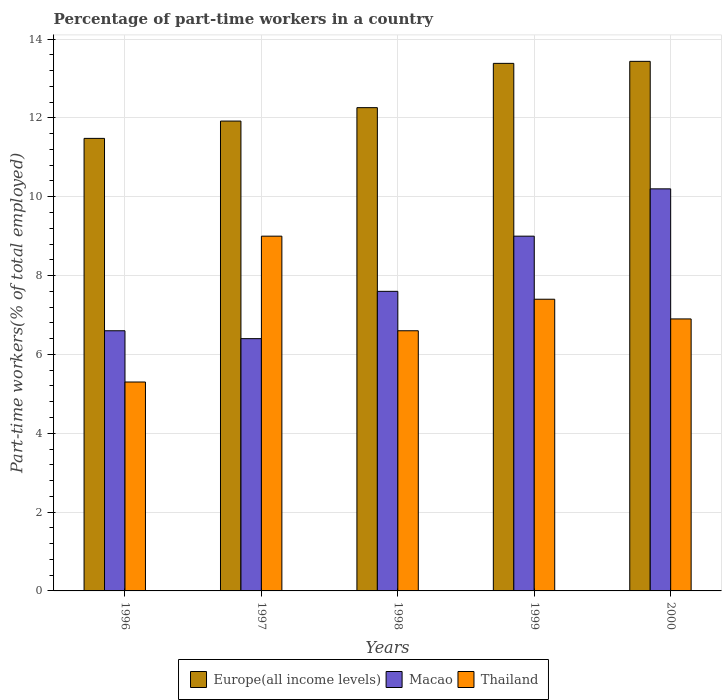How many different coloured bars are there?
Offer a very short reply. 3. How many bars are there on the 5th tick from the right?
Ensure brevity in your answer.  3. What is the label of the 5th group of bars from the left?
Provide a short and direct response. 2000. In how many cases, is the number of bars for a given year not equal to the number of legend labels?
Offer a very short reply. 0. What is the percentage of part-time workers in Macao in 1996?
Provide a succinct answer. 6.6. Across all years, what is the maximum percentage of part-time workers in Macao?
Your answer should be compact. 10.2. Across all years, what is the minimum percentage of part-time workers in Macao?
Keep it short and to the point. 6.4. What is the total percentage of part-time workers in Europe(all income levels) in the graph?
Ensure brevity in your answer.  62.48. What is the difference between the percentage of part-time workers in Macao in 1997 and that in 2000?
Offer a terse response. -3.8. What is the difference between the percentage of part-time workers in Thailand in 2000 and the percentage of part-time workers in Macao in 1997?
Offer a very short reply. 0.5. What is the average percentage of part-time workers in Europe(all income levels) per year?
Offer a very short reply. 12.5. In the year 1998, what is the difference between the percentage of part-time workers in Europe(all income levels) and percentage of part-time workers in Macao?
Your answer should be compact. 4.66. What is the ratio of the percentage of part-time workers in Macao in 1996 to that in 1998?
Offer a very short reply. 0.87. Is the percentage of part-time workers in Macao in 1996 less than that in 1999?
Provide a succinct answer. Yes. Is the difference between the percentage of part-time workers in Europe(all income levels) in 1996 and 1998 greater than the difference between the percentage of part-time workers in Macao in 1996 and 1998?
Provide a succinct answer. Yes. What is the difference between the highest and the second highest percentage of part-time workers in Macao?
Ensure brevity in your answer.  1.2. What is the difference between the highest and the lowest percentage of part-time workers in Thailand?
Keep it short and to the point. 3.7. In how many years, is the percentage of part-time workers in Macao greater than the average percentage of part-time workers in Macao taken over all years?
Offer a very short reply. 2. What does the 1st bar from the left in 1998 represents?
Give a very brief answer. Europe(all income levels). What does the 2nd bar from the right in 1998 represents?
Keep it short and to the point. Macao. Is it the case that in every year, the sum of the percentage of part-time workers in Macao and percentage of part-time workers in Thailand is greater than the percentage of part-time workers in Europe(all income levels)?
Offer a terse response. Yes. How many bars are there?
Offer a terse response. 15. Are all the bars in the graph horizontal?
Ensure brevity in your answer.  No. Does the graph contain any zero values?
Your answer should be compact. No. How are the legend labels stacked?
Offer a very short reply. Horizontal. What is the title of the graph?
Provide a succinct answer. Percentage of part-time workers in a country. Does "Tuvalu" appear as one of the legend labels in the graph?
Your answer should be compact. No. What is the label or title of the Y-axis?
Give a very brief answer. Part-time workers(% of total employed). What is the Part-time workers(% of total employed) of Europe(all income levels) in 1996?
Your answer should be very brief. 11.48. What is the Part-time workers(% of total employed) in Macao in 1996?
Offer a terse response. 6.6. What is the Part-time workers(% of total employed) of Thailand in 1996?
Make the answer very short. 5.3. What is the Part-time workers(% of total employed) of Europe(all income levels) in 1997?
Make the answer very short. 11.92. What is the Part-time workers(% of total employed) of Macao in 1997?
Ensure brevity in your answer.  6.4. What is the Part-time workers(% of total employed) in Thailand in 1997?
Make the answer very short. 9. What is the Part-time workers(% of total employed) of Europe(all income levels) in 1998?
Offer a very short reply. 12.26. What is the Part-time workers(% of total employed) of Macao in 1998?
Offer a terse response. 7.6. What is the Part-time workers(% of total employed) of Thailand in 1998?
Offer a terse response. 6.6. What is the Part-time workers(% of total employed) in Europe(all income levels) in 1999?
Give a very brief answer. 13.38. What is the Part-time workers(% of total employed) in Macao in 1999?
Keep it short and to the point. 9. What is the Part-time workers(% of total employed) in Thailand in 1999?
Your answer should be compact. 7.4. What is the Part-time workers(% of total employed) of Europe(all income levels) in 2000?
Offer a very short reply. 13.43. What is the Part-time workers(% of total employed) of Macao in 2000?
Your answer should be very brief. 10.2. What is the Part-time workers(% of total employed) in Thailand in 2000?
Make the answer very short. 6.9. Across all years, what is the maximum Part-time workers(% of total employed) in Europe(all income levels)?
Your answer should be compact. 13.43. Across all years, what is the maximum Part-time workers(% of total employed) of Macao?
Offer a very short reply. 10.2. Across all years, what is the maximum Part-time workers(% of total employed) of Thailand?
Your answer should be compact. 9. Across all years, what is the minimum Part-time workers(% of total employed) in Europe(all income levels)?
Give a very brief answer. 11.48. Across all years, what is the minimum Part-time workers(% of total employed) in Macao?
Offer a very short reply. 6.4. Across all years, what is the minimum Part-time workers(% of total employed) in Thailand?
Make the answer very short. 5.3. What is the total Part-time workers(% of total employed) in Europe(all income levels) in the graph?
Give a very brief answer. 62.48. What is the total Part-time workers(% of total employed) of Macao in the graph?
Offer a terse response. 39.8. What is the total Part-time workers(% of total employed) of Thailand in the graph?
Your response must be concise. 35.2. What is the difference between the Part-time workers(% of total employed) in Europe(all income levels) in 1996 and that in 1997?
Keep it short and to the point. -0.44. What is the difference between the Part-time workers(% of total employed) in Macao in 1996 and that in 1997?
Provide a succinct answer. 0.2. What is the difference between the Part-time workers(% of total employed) of Europe(all income levels) in 1996 and that in 1998?
Make the answer very short. -0.78. What is the difference between the Part-time workers(% of total employed) in Macao in 1996 and that in 1998?
Offer a terse response. -1. What is the difference between the Part-time workers(% of total employed) of Europe(all income levels) in 1996 and that in 1999?
Provide a succinct answer. -1.9. What is the difference between the Part-time workers(% of total employed) of Macao in 1996 and that in 1999?
Offer a very short reply. -2.4. What is the difference between the Part-time workers(% of total employed) of Thailand in 1996 and that in 1999?
Your answer should be compact. -2.1. What is the difference between the Part-time workers(% of total employed) in Europe(all income levels) in 1996 and that in 2000?
Your answer should be very brief. -1.95. What is the difference between the Part-time workers(% of total employed) of Thailand in 1996 and that in 2000?
Keep it short and to the point. -1.6. What is the difference between the Part-time workers(% of total employed) of Europe(all income levels) in 1997 and that in 1998?
Give a very brief answer. -0.34. What is the difference between the Part-time workers(% of total employed) of Thailand in 1997 and that in 1998?
Provide a short and direct response. 2.4. What is the difference between the Part-time workers(% of total employed) of Europe(all income levels) in 1997 and that in 1999?
Give a very brief answer. -1.46. What is the difference between the Part-time workers(% of total employed) in Thailand in 1997 and that in 1999?
Your answer should be very brief. 1.6. What is the difference between the Part-time workers(% of total employed) in Europe(all income levels) in 1997 and that in 2000?
Your response must be concise. -1.51. What is the difference between the Part-time workers(% of total employed) of Europe(all income levels) in 1998 and that in 1999?
Offer a terse response. -1.12. What is the difference between the Part-time workers(% of total employed) of Thailand in 1998 and that in 1999?
Your answer should be very brief. -0.8. What is the difference between the Part-time workers(% of total employed) in Europe(all income levels) in 1998 and that in 2000?
Ensure brevity in your answer.  -1.17. What is the difference between the Part-time workers(% of total employed) in Macao in 1998 and that in 2000?
Provide a short and direct response. -2.6. What is the difference between the Part-time workers(% of total employed) of Europe(all income levels) in 1999 and that in 2000?
Provide a short and direct response. -0.05. What is the difference between the Part-time workers(% of total employed) of Macao in 1999 and that in 2000?
Offer a terse response. -1.2. What is the difference between the Part-time workers(% of total employed) of Thailand in 1999 and that in 2000?
Keep it short and to the point. 0.5. What is the difference between the Part-time workers(% of total employed) in Europe(all income levels) in 1996 and the Part-time workers(% of total employed) in Macao in 1997?
Ensure brevity in your answer.  5.08. What is the difference between the Part-time workers(% of total employed) in Europe(all income levels) in 1996 and the Part-time workers(% of total employed) in Thailand in 1997?
Provide a succinct answer. 2.48. What is the difference between the Part-time workers(% of total employed) of Europe(all income levels) in 1996 and the Part-time workers(% of total employed) of Macao in 1998?
Offer a very short reply. 3.88. What is the difference between the Part-time workers(% of total employed) of Europe(all income levels) in 1996 and the Part-time workers(% of total employed) of Thailand in 1998?
Ensure brevity in your answer.  4.88. What is the difference between the Part-time workers(% of total employed) of Macao in 1996 and the Part-time workers(% of total employed) of Thailand in 1998?
Offer a very short reply. 0. What is the difference between the Part-time workers(% of total employed) of Europe(all income levels) in 1996 and the Part-time workers(% of total employed) of Macao in 1999?
Your answer should be compact. 2.48. What is the difference between the Part-time workers(% of total employed) in Europe(all income levels) in 1996 and the Part-time workers(% of total employed) in Thailand in 1999?
Provide a succinct answer. 4.08. What is the difference between the Part-time workers(% of total employed) of Macao in 1996 and the Part-time workers(% of total employed) of Thailand in 1999?
Your answer should be very brief. -0.8. What is the difference between the Part-time workers(% of total employed) of Europe(all income levels) in 1996 and the Part-time workers(% of total employed) of Macao in 2000?
Make the answer very short. 1.28. What is the difference between the Part-time workers(% of total employed) in Europe(all income levels) in 1996 and the Part-time workers(% of total employed) in Thailand in 2000?
Offer a terse response. 4.58. What is the difference between the Part-time workers(% of total employed) of Macao in 1996 and the Part-time workers(% of total employed) of Thailand in 2000?
Offer a very short reply. -0.3. What is the difference between the Part-time workers(% of total employed) in Europe(all income levels) in 1997 and the Part-time workers(% of total employed) in Macao in 1998?
Your answer should be very brief. 4.32. What is the difference between the Part-time workers(% of total employed) in Europe(all income levels) in 1997 and the Part-time workers(% of total employed) in Thailand in 1998?
Your answer should be very brief. 5.32. What is the difference between the Part-time workers(% of total employed) of Macao in 1997 and the Part-time workers(% of total employed) of Thailand in 1998?
Provide a short and direct response. -0.2. What is the difference between the Part-time workers(% of total employed) of Europe(all income levels) in 1997 and the Part-time workers(% of total employed) of Macao in 1999?
Keep it short and to the point. 2.92. What is the difference between the Part-time workers(% of total employed) of Europe(all income levels) in 1997 and the Part-time workers(% of total employed) of Thailand in 1999?
Provide a short and direct response. 4.52. What is the difference between the Part-time workers(% of total employed) of Macao in 1997 and the Part-time workers(% of total employed) of Thailand in 1999?
Make the answer very short. -1. What is the difference between the Part-time workers(% of total employed) in Europe(all income levels) in 1997 and the Part-time workers(% of total employed) in Macao in 2000?
Your answer should be very brief. 1.72. What is the difference between the Part-time workers(% of total employed) of Europe(all income levels) in 1997 and the Part-time workers(% of total employed) of Thailand in 2000?
Provide a short and direct response. 5.02. What is the difference between the Part-time workers(% of total employed) of Europe(all income levels) in 1998 and the Part-time workers(% of total employed) of Macao in 1999?
Offer a terse response. 3.26. What is the difference between the Part-time workers(% of total employed) in Europe(all income levels) in 1998 and the Part-time workers(% of total employed) in Thailand in 1999?
Offer a very short reply. 4.86. What is the difference between the Part-time workers(% of total employed) of Europe(all income levels) in 1998 and the Part-time workers(% of total employed) of Macao in 2000?
Ensure brevity in your answer.  2.06. What is the difference between the Part-time workers(% of total employed) of Europe(all income levels) in 1998 and the Part-time workers(% of total employed) of Thailand in 2000?
Your answer should be compact. 5.36. What is the difference between the Part-time workers(% of total employed) in Europe(all income levels) in 1999 and the Part-time workers(% of total employed) in Macao in 2000?
Keep it short and to the point. 3.18. What is the difference between the Part-time workers(% of total employed) of Europe(all income levels) in 1999 and the Part-time workers(% of total employed) of Thailand in 2000?
Ensure brevity in your answer.  6.48. What is the average Part-time workers(% of total employed) in Europe(all income levels) per year?
Offer a terse response. 12.5. What is the average Part-time workers(% of total employed) of Macao per year?
Give a very brief answer. 7.96. What is the average Part-time workers(% of total employed) of Thailand per year?
Your answer should be compact. 7.04. In the year 1996, what is the difference between the Part-time workers(% of total employed) in Europe(all income levels) and Part-time workers(% of total employed) in Macao?
Ensure brevity in your answer.  4.88. In the year 1996, what is the difference between the Part-time workers(% of total employed) in Europe(all income levels) and Part-time workers(% of total employed) in Thailand?
Offer a very short reply. 6.18. In the year 1996, what is the difference between the Part-time workers(% of total employed) of Macao and Part-time workers(% of total employed) of Thailand?
Offer a very short reply. 1.3. In the year 1997, what is the difference between the Part-time workers(% of total employed) in Europe(all income levels) and Part-time workers(% of total employed) in Macao?
Offer a terse response. 5.52. In the year 1997, what is the difference between the Part-time workers(% of total employed) of Europe(all income levels) and Part-time workers(% of total employed) of Thailand?
Ensure brevity in your answer.  2.92. In the year 1997, what is the difference between the Part-time workers(% of total employed) of Macao and Part-time workers(% of total employed) of Thailand?
Give a very brief answer. -2.6. In the year 1998, what is the difference between the Part-time workers(% of total employed) of Europe(all income levels) and Part-time workers(% of total employed) of Macao?
Your answer should be compact. 4.66. In the year 1998, what is the difference between the Part-time workers(% of total employed) of Europe(all income levels) and Part-time workers(% of total employed) of Thailand?
Offer a terse response. 5.66. In the year 1999, what is the difference between the Part-time workers(% of total employed) in Europe(all income levels) and Part-time workers(% of total employed) in Macao?
Ensure brevity in your answer.  4.38. In the year 1999, what is the difference between the Part-time workers(% of total employed) in Europe(all income levels) and Part-time workers(% of total employed) in Thailand?
Give a very brief answer. 5.98. In the year 2000, what is the difference between the Part-time workers(% of total employed) of Europe(all income levels) and Part-time workers(% of total employed) of Macao?
Make the answer very short. 3.23. In the year 2000, what is the difference between the Part-time workers(% of total employed) in Europe(all income levels) and Part-time workers(% of total employed) in Thailand?
Ensure brevity in your answer.  6.53. What is the ratio of the Part-time workers(% of total employed) of Europe(all income levels) in 1996 to that in 1997?
Offer a very short reply. 0.96. What is the ratio of the Part-time workers(% of total employed) in Macao in 1996 to that in 1997?
Your response must be concise. 1.03. What is the ratio of the Part-time workers(% of total employed) of Thailand in 1996 to that in 1997?
Your response must be concise. 0.59. What is the ratio of the Part-time workers(% of total employed) in Europe(all income levels) in 1996 to that in 1998?
Ensure brevity in your answer.  0.94. What is the ratio of the Part-time workers(% of total employed) in Macao in 1996 to that in 1998?
Give a very brief answer. 0.87. What is the ratio of the Part-time workers(% of total employed) of Thailand in 1996 to that in 1998?
Offer a very short reply. 0.8. What is the ratio of the Part-time workers(% of total employed) of Europe(all income levels) in 1996 to that in 1999?
Your answer should be compact. 0.86. What is the ratio of the Part-time workers(% of total employed) in Macao in 1996 to that in 1999?
Offer a very short reply. 0.73. What is the ratio of the Part-time workers(% of total employed) of Thailand in 1996 to that in 1999?
Ensure brevity in your answer.  0.72. What is the ratio of the Part-time workers(% of total employed) of Europe(all income levels) in 1996 to that in 2000?
Offer a very short reply. 0.85. What is the ratio of the Part-time workers(% of total employed) of Macao in 1996 to that in 2000?
Provide a short and direct response. 0.65. What is the ratio of the Part-time workers(% of total employed) in Thailand in 1996 to that in 2000?
Ensure brevity in your answer.  0.77. What is the ratio of the Part-time workers(% of total employed) of Europe(all income levels) in 1997 to that in 1998?
Provide a succinct answer. 0.97. What is the ratio of the Part-time workers(% of total employed) of Macao in 1997 to that in 1998?
Keep it short and to the point. 0.84. What is the ratio of the Part-time workers(% of total employed) of Thailand in 1997 to that in 1998?
Provide a short and direct response. 1.36. What is the ratio of the Part-time workers(% of total employed) in Europe(all income levels) in 1997 to that in 1999?
Offer a terse response. 0.89. What is the ratio of the Part-time workers(% of total employed) of Macao in 1997 to that in 1999?
Your response must be concise. 0.71. What is the ratio of the Part-time workers(% of total employed) in Thailand in 1997 to that in 1999?
Your response must be concise. 1.22. What is the ratio of the Part-time workers(% of total employed) in Europe(all income levels) in 1997 to that in 2000?
Provide a short and direct response. 0.89. What is the ratio of the Part-time workers(% of total employed) of Macao in 1997 to that in 2000?
Make the answer very short. 0.63. What is the ratio of the Part-time workers(% of total employed) of Thailand in 1997 to that in 2000?
Provide a succinct answer. 1.3. What is the ratio of the Part-time workers(% of total employed) of Europe(all income levels) in 1998 to that in 1999?
Keep it short and to the point. 0.92. What is the ratio of the Part-time workers(% of total employed) in Macao in 1998 to that in 1999?
Offer a terse response. 0.84. What is the ratio of the Part-time workers(% of total employed) in Thailand in 1998 to that in 1999?
Provide a succinct answer. 0.89. What is the ratio of the Part-time workers(% of total employed) in Europe(all income levels) in 1998 to that in 2000?
Make the answer very short. 0.91. What is the ratio of the Part-time workers(% of total employed) in Macao in 1998 to that in 2000?
Make the answer very short. 0.75. What is the ratio of the Part-time workers(% of total employed) of Thailand in 1998 to that in 2000?
Offer a very short reply. 0.96. What is the ratio of the Part-time workers(% of total employed) of Europe(all income levels) in 1999 to that in 2000?
Provide a succinct answer. 1. What is the ratio of the Part-time workers(% of total employed) in Macao in 1999 to that in 2000?
Give a very brief answer. 0.88. What is the ratio of the Part-time workers(% of total employed) in Thailand in 1999 to that in 2000?
Your answer should be very brief. 1.07. What is the difference between the highest and the second highest Part-time workers(% of total employed) in Europe(all income levels)?
Offer a very short reply. 0.05. What is the difference between the highest and the second highest Part-time workers(% of total employed) in Macao?
Offer a very short reply. 1.2. What is the difference between the highest and the second highest Part-time workers(% of total employed) in Thailand?
Give a very brief answer. 1.6. What is the difference between the highest and the lowest Part-time workers(% of total employed) in Europe(all income levels)?
Provide a succinct answer. 1.95. What is the difference between the highest and the lowest Part-time workers(% of total employed) in Macao?
Keep it short and to the point. 3.8. 